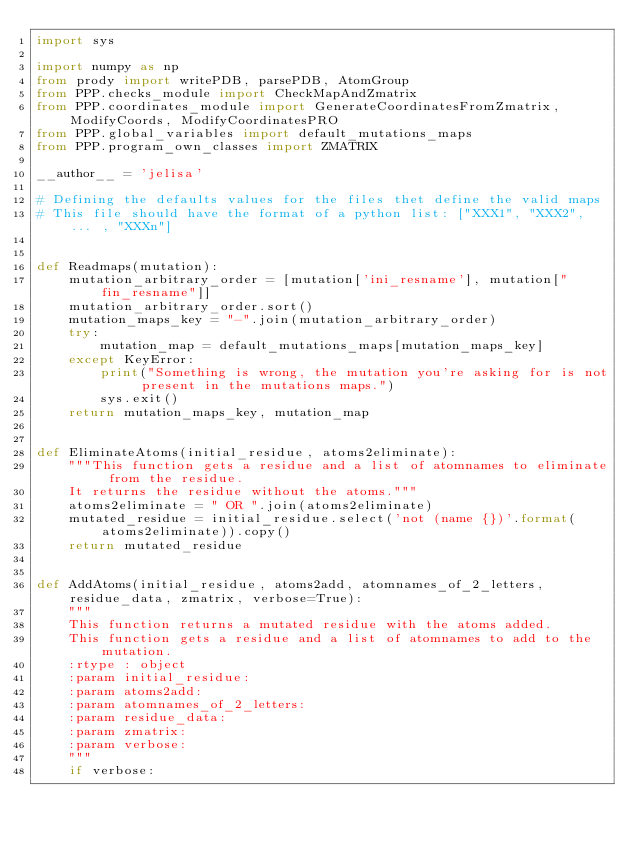Convert code to text. <code><loc_0><loc_0><loc_500><loc_500><_Python_>import sys

import numpy as np
from prody import writePDB, parsePDB, AtomGroup
from PPP.checks_module import CheckMapAndZmatrix
from PPP.coordinates_module import GenerateCoordinatesFromZmatrix, ModifyCoords, ModifyCoordinatesPRO
from PPP.global_variables import default_mutations_maps
from PPP.program_own_classes import ZMATRIX

__author__ = 'jelisa'

# Defining the defaults values for the files thet define the valid maps
# This file should have the format of a python list: ["XXX1", "XXX2", ... , "XXXn"]


def Readmaps(mutation):
    mutation_arbitrary_order = [mutation['ini_resname'], mutation["fin_resname"]]
    mutation_arbitrary_order.sort()
    mutation_maps_key = "-".join(mutation_arbitrary_order)
    try:
        mutation_map = default_mutations_maps[mutation_maps_key]
    except KeyError:
        print("Something is wrong, the mutation you're asking for is not present in the mutations maps.")
        sys.exit()
    return mutation_maps_key, mutation_map


def EliminateAtoms(initial_residue, atoms2eliminate):
    """This function gets a residue and a list of atomnames to eliminate from the residue.
    It returns the residue without the atoms."""
    atoms2eliminate = " OR ".join(atoms2eliminate)
    mutated_residue = initial_residue.select('not (name {})'.format(atoms2eliminate)).copy()
    return mutated_residue


def AddAtoms(initial_residue, atoms2add, atomnames_of_2_letters, residue_data, zmatrix, verbose=True):
    """
    This function returns a mutated residue with the atoms added.
    This function gets a residue and a list of atomnames to add to the mutation.
    :rtype : object
    :param initial_residue:
    :param atoms2add: 
    :param atomnames_of_2_letters: 
    :param residue_data: 
    :param zmatrix: 
    :param verbose: 
    """
    if verbose:</code> 